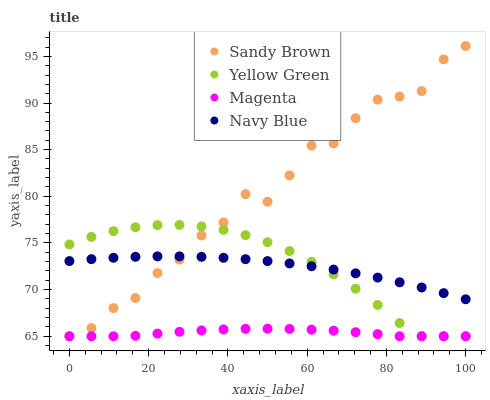Does Magenta have the minimum area under the curve?
Answer yes or no. Yes. Does Sandy Brown have the maximum area under the curve?
Answer yes or no. Yes. Does Sandy Brown have the minimum area under the curve?
Answer yes or no. No. Does Magenta have the maximum area under the curve?
Answer yes or no. No. Is Navy Blue the smoothest?
Answer yes or no. Yes. Is Sandy Brown the roughest?
Answer yes or no. Yes. Is Magenta the smoothest?
Answer yes or no. No. Is Magenta the roughest?
Answer yes or no. No. Does Magenta have the lowest value?
Answer yes or no. Yes. Does Sandy Brown have the highest value?
Answer yes or no. Yes. Does Magenta have the highest value?
Answer yes or no. No. Is Magenta less than Navy Blue?
Answer yes or no. Yes. Is Navy Blue greater than Magenta?
Answer yes or no. Yes. Does Magenta intersect Sandy Brown?
Answer yes or no. Yes. Is Magenta less than Sandy Brown?
Answer yes or no. No. Is Magenta greater than Sandy Brown?
Answer yes or no. No. Does Magenta intersect Navy Blue?
Answer yes or no. No. 